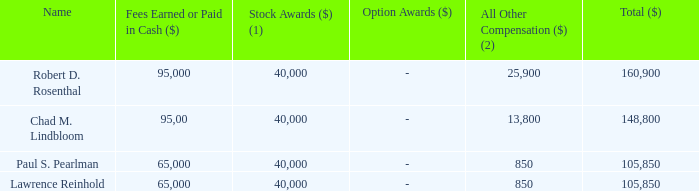Non-Management Director Compensation in Fiscal 2019
The non-management directors received the following compensation during fiscal 2019:
(1) This column represents the fair value of the stock award on the grant date determined in accordance with the provisions of ASC 718. As per SEC rules relating to executive compensation disclosure, the amounts shown exclude the impact of forfeitures related to service based vesting conditions. For additional information regarding assumptions made in calculating the amount reflected in this column, please refer to Note 10 to our audited consolidated financial statements, included in our Annual Report on Form 10-K for fiscal 2019.
(2) Dividend equivalent payments on unvested restricted stock.
What is the total compensation received by Robert D. Rosenthal and Chad M. Lindbloom respectively during fiscal 2019? 160,900, 148,800. What is the total compensation received by Paul S. Pearlman and Lawrence Reinhold respectively during fiscal 2019? 105,850, 105,850. What does stock awards refer to? Represents the fair value of the stock award on the grant date determined in accordance with the provisions of asc 718. What is the total compensation received by Robert D. Rosenthal and Chad M. Lindbloom during fiscal 2019? 160,900 + 148,800 
Answer: 309700. What is the total compensation received by Paul S. Pearlman and Lawrence Reinhold during fiscal 2019? 105,850 + 105,850 
Answer: 211700. What is the percentage of Pearlman's fees earned in cash as a percentage of his total compensation during fiscal 2019?
Answer scale should be: percent. 65,000/105,850 
Answer: 61.41. 